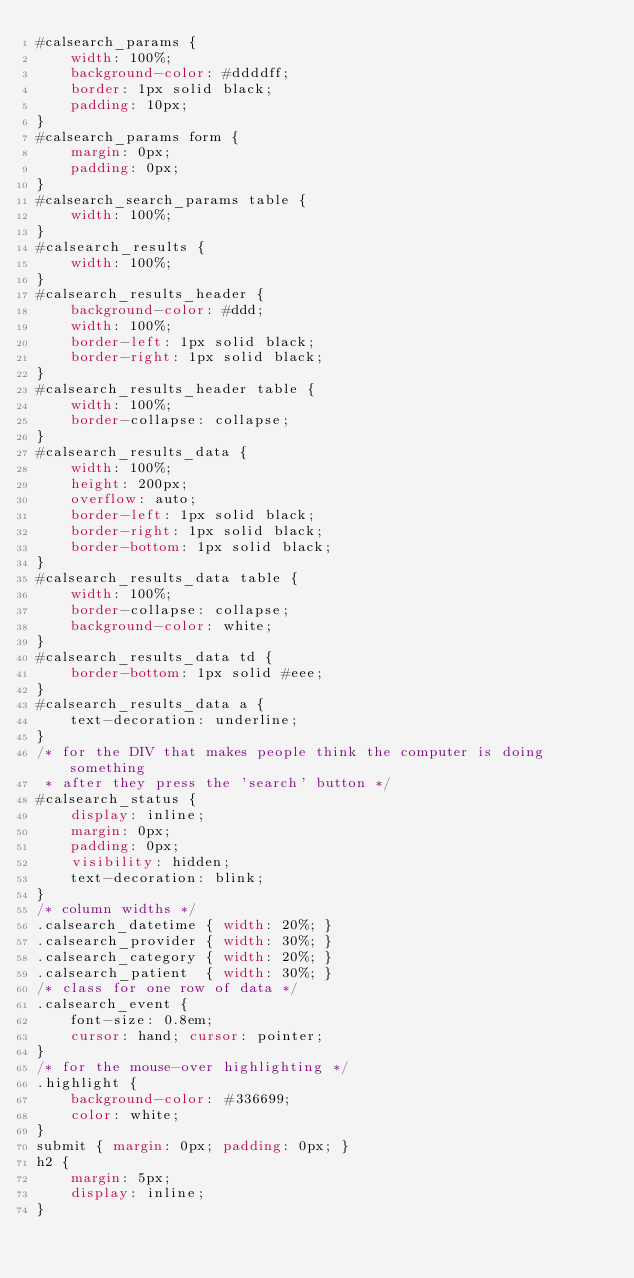Convert code to text. <code><loc_0><loc_0><loc_500><loc_500><_CSS_>#calsearch_params {
    width: 100%;
    background-color: #ddddff;
    border: 1px solid black;
    padding: 10px;
}
#calsearch_params form {
    margin: 0px;
    padding: 0px;
}
#calsearch_search_params table {
    width: 100%;
}
#calsearch_results {
    width: 100%;
}
#calsearch_results_header {
    background-color: #ddd;
    width: 100%;
    border-left: 1px solid black;
    border-right: 1px solid black;
}
#calsearch_results_header table {
    width: 100%;
    border-collapse: collapse;
}
#calsearch_results_data {
    width: 100%;
    height: 200px;
    overflow: auto;
    border-left: 1px solid black;
    border-right: 1px solid black;
    border-bottom: 1px solid black;
}
#calsearch_results_data table {
    width: 100%;
    border-collapse: collapse;
    background-color: white;
}
#calsearch_results_data td {
    border-bottom: 1px solid #eee;
}
#calsearch_results_data a {
    text-decoration: underline;
}
/* for the DIV that makes people think the computer is doing something 
 * after they press the 'search' button */
#calsearch_status {
    display: inline;
    margin: 0px;
    padding: 0px;
    visibility: hidden;
    text-decoration: blink;
}
/* column widths */
.calsearch_datetime { width: 20%; }
.calsearch_provider { width: 30%; }
.calsearch_category { width: 20%; }
.calsearch_patient  { width: 30%; }
/* class for one row of data */
.calsearch_event {
    font-size: 0.8em;
    cursor: hand; cursor: pointer;
}
/* for the mouse-over highlighting */
.highlight {
    background-color: #336699;
    color: white;
}
submit { margin: 0px; padding: 0px; }
h2 {
    margin: 5px;
    display: inline;
}
</code> 